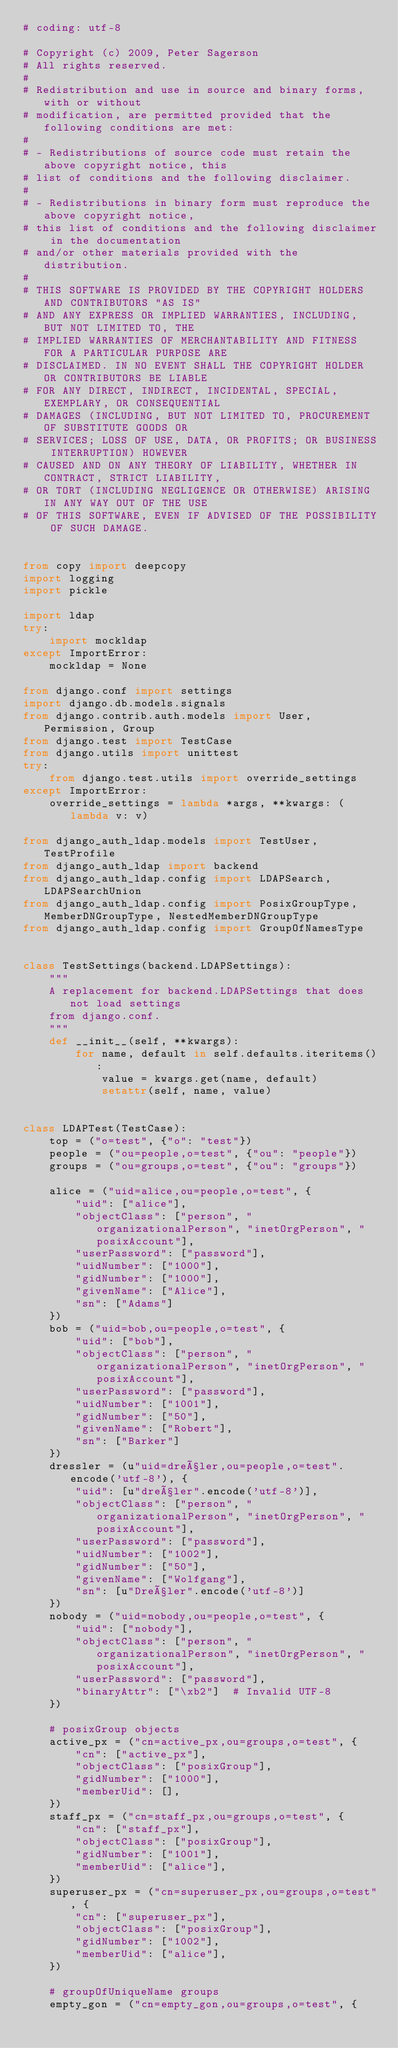<code> <loc_0><loc_0><loc_500><loc_500><_Python_># coding: utf-8

# Copyright (c) 2009, Peter Sagerson
# All rights reserved.
#
# Redistribution and use in source and binary forms, with or without
# modification, are permitted provided that the following conditions are met:
#
# - Redistributions of source code must retain the above copyright notice, this
# list of conditions and the following disclaimer.
#
# - Redistributions in binary form must reproduce the above copyright notice,
# this list of conditions and the following disclaimer in the documentation
# and/or other materials provided with the distribution.
#
# THIS SOFTWARE IS PROVIDED BY THE COPYRIGHT HOLDERS AND CONTRIBUTORS "AS IS"
# AND ANY EXPRESS OR IMPLIED WARRANTIES, INCLUDING, BUT NOT LIMITED TO, THE
# IMPLIED WARRANTIES OF MERCHANTABILITY AND FITNESS FOR A PARTICULAR PURPOSE ARE
# DISCLAIMED. IN NO EVENT SHALL THE COPYRIGHT HOLDER OR CONTRIBUTORS BE LIABLE
# FOR ANY DIRECT, INDIRECT, INCIDENTAL, SPECIAL, EXEMPLARY, OR CONSEQUENTIAL
# DAMAGES (INCLUDING, BUT NOT LIMITED TO, PROCUREMENT OF SUBSTITUTE GOODS OR
# SERVICES; LOSS OF USE, DATA, OR PROFITS; OR BUSINESS INTERRUPTION) HOWEVER
# CAUSED AND ON ANY THEORY OF LIABILITY, WHETHER IN CONTRACT, STRICT LIABILITY,
# OR TORT (INCLUDING NEGLIGENCE OR OTHERWISE) ARISING IN ANY WAY OUT OF THE USE
# OF THIS SOFTWARE, EVEN IF ADVISED OF THE POSSIBILITY OF SUCH DAMAGE.


from copy import deepcopy
import logging
import pickle

import ldap
try:
    import mockldap
except ImportError:
    mockldap = None

from django.conf import settings
import django.db.models.signals
from django.contrib.auth.models import User, Permission, Group
from django.test import TestCase
from django.utils import unittest
try:
    from django.test.utils import override_settings
except ImportError:
    override_settings = lambda *args, **kwargs: (lambda v: v)

from django_auth_ldap.models import TestUser, TestProfile
from django_auth_ldap import backend
from django_auth_ldap.config import LDAPSearch, LDAPSearchUnion
from django_auth_ldap.config import PosixGroupType, MemberDNGroupType, NestedMemberDNGroupType
from django_auth_ldap.config import GroupOfNamesType


class TestSettings(backend.LDAPSettings):
    """
    A replacement for backend.LDAPSettings that does not load settings
    from django.conf.
    """
    def __init__(self, **kwargs):
        for name, default in self.defaults.iteritems():
            value = kwargs.get(name, default)
            setattr(self, name, value)


class LDAPTest(TestCase):
    top = ("o=test", {"o": "test"})
    people = ("ou=people,o=test", {"ou": "people"})
    groups = ("ou=groups,o=test", {"ou": "groups"})

    alice = ("uid=alice,ou=people,o=test", {
        "uid": ["alice"],
        "objectClass": ["person", "organizationalPerson", "inetOrgPerson", "posixAccount"],
        "userPassword": ["password"],
        "uidNumber": ["1000"],
        "gidNumber": ["1000"],
        "givenName": ["Alice"],
        "sn": ["Adams"]
    })
    bob = ("uid=bob,ou=people,o=test", {
        "uid": ["bob"],
        "objectClass": ["person", "organizationalPerson", "inetOrgPerson", "posixAccount"],
        "userPassword": ["password"],
        "uidNumber": ["1001"],
        "gidNumber": ["50"],
        "givenName": ["Robert"],
        "sn": ["Barker"]
    })
    dressler = (u"uid=dreßler,ou=people,o=test".encode('utf-8'), {
        "uid": [u"dreßler".encode('utf-8')],
        "objectClass": ["person", "organizationalPerson", "inetOrgPerson", "posixAccount"],
        "userPassword": ["password"],
        "uidNumber": ["1002"],
        "gidNumber": ["50"],
        "givenName": ["Wolfgang"],
        "sn": [u"Dreßler".encode('utf-8')]
    })
    nobody = ("uid=nobody,ou=people,o=test", {
        "uid": ["nobody"],
        "objectClass": ["person", "organizationalPerson", "inetOrgPerson", "posixAccount"],
        "userPassword": ["password"],
        "binaryAttr": ["\xb2"]  # Invalid UTF-8
    })

    # posixGroup objects
    active_px = ("cn=active_px,ou=groups,o=test", {
        "cn": ["active_px"],
        "objectClass": ["posixGroup"],
        "gidNumber": ["1000"],
        "memberUid": [],
    })
    staff_px = ("cn=staff_px,ou=groups,o=test", {
        "cn": ["staff_px"],
        "objectClass": ["posixGroup"],
        "gidNumber": ["1001"],
        "memberUid": ["alice"],
    })
    superuser_px = ("cn=superuser_px,ou=groups,o=test", {
        "cn": ["superuser_px"],
        "objectClass": ["posixGroup"],
        "gidNumber": ["1002"],
        "memberUid": ["alice"],
    })

    # groupOfUniqueName groups
    empty_gon = ("cn=empty_gon,ou=groups,o=test", {</code> 